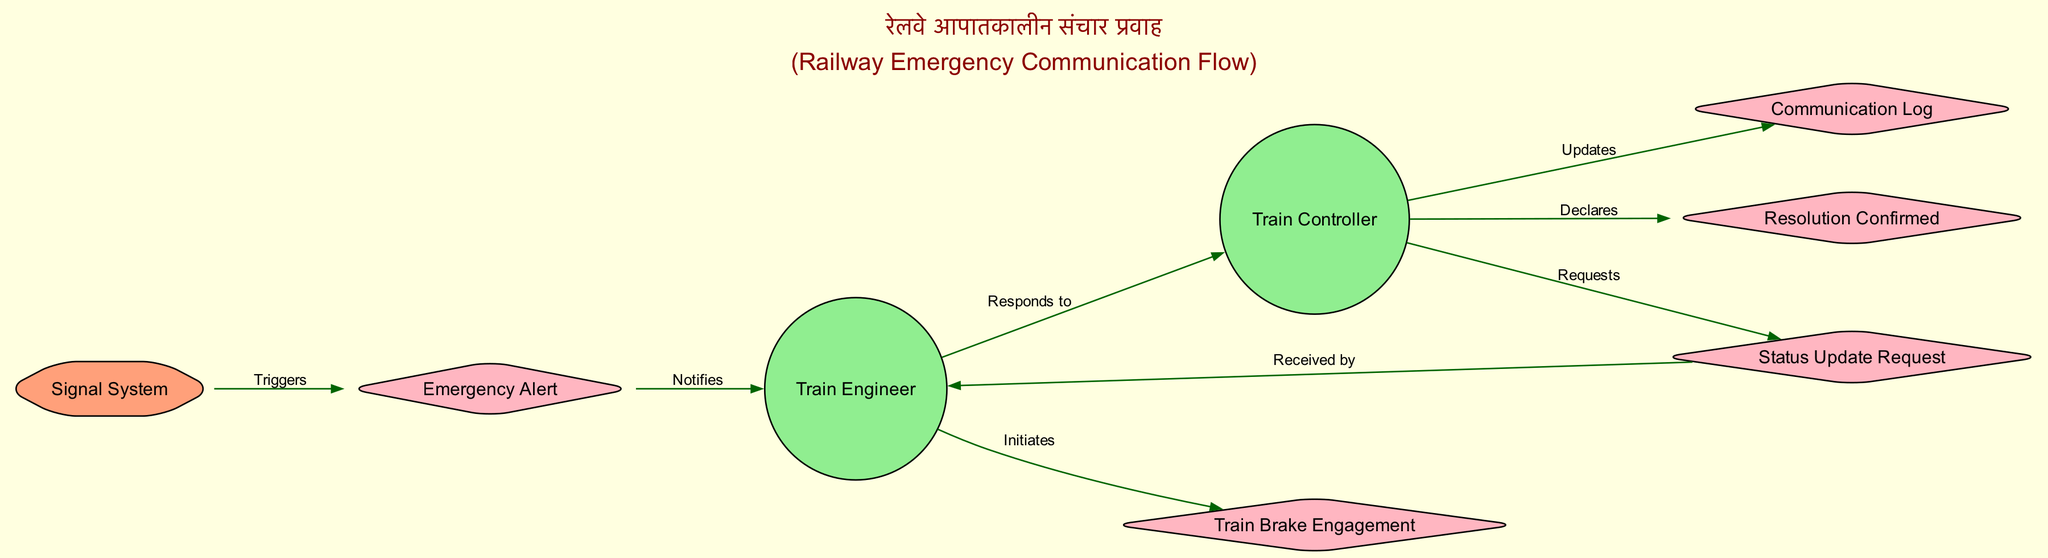What is the first event triggered in the communication flow? The first event shown in the diagram is the "Emergency Alert," which is triggered by the Signal System as part of the communication flow during an emergency.
Answer: Emergency Alert How many actors are there in the diagram? The diagram contains two actors: the Train Engineer and the Train Controller.
Answer: 2 What action does the Train Engineer take after receiving the emergency alert? After receiving the emergency alert, the Train Engineer initiates the "Train Brake Engagement," which is the action taken to slow or stop the train.
Answer: Initiates Who requests the current status during the emergency? The "Train Controller" is responsible for requesting the current status during the emergency situation, as depicted in the communication flow.
Answer: Train Controller Which event leads to the Train Engineer responding to the Train Controller? The "Status Update Request" sent from the Train Controller to the Train Engineer leads to the Train Engineer responding, as indicated in the sequence of events.
Answer: Status Update Request What does the Train Controller do after resolving the emergency? After resolving the emergency, the Train Controller declares or confirms that the situation has been resolved, which is an important step in closing the communication loop.
Answer: Declares How does the Signal System influence the flow of communication? The Signal System triggers the “Emergency Alert,” initiating the communication flow with associated responses from both the Train Engineer and the Train Controller.
Answer: Triggers What is maintained by the Train Controller throughout the emergency? The Train Controller maintains a "Communication Log," which records all communications that take place during the emergency situation to ensure a proper account of actions and decisions.
Answer: Communication Log 